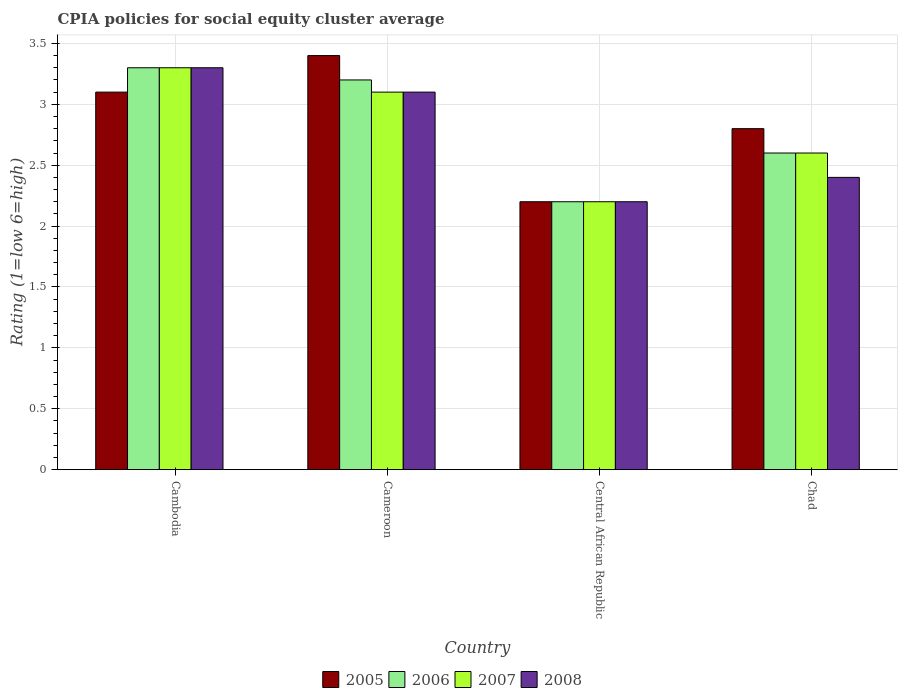How many different coloured bars are there?
Provide a succinct answer. 4. How many groups of bars are there?
Make the answer very short. 4. Are the number of bars on each tick of the X-axis equal?
Your response must be concise. Yes. How many bars are there on the 2nd tick from the right?
Your answer should be very brief. 4. What is the label of the 4th group of bars from the left?
Keep it short and to the point. Chad. What is the CPIA rating in 2008 in Cameroon?
Ensure brevity in your answer.  3.1. Across all countries, what is the maximum CPIA rating in 2005?
Your response must be concise. 3.4. In which country was the CPIA rating in 2006 maximum?
Ensure brevity in your answer.  Cambodia. In which country was the CPIA rating in 2005 minimum?
Keep it short and to the point. Central African Republic. What is the total CPIA rating in 2005 in the graph?
Your response must be concise. 11.5. What is the difference between the CPIA rating in 2008 in Cameroon and that in Chad?
Offer a very short reply. 0.7. What is the difference between the CPIA rating in 2005 in Cambodia and the CPIA rating in 2008 in Chad?
Offer a terse response. 0.7. What is the average CPIA rating in 2006 per country?
Make the answer very short. 2.82. What is the difference between the CPIA rating of/in 2005 and CPIA rating of/in 2007 in Cambodia?
Offer a terse response. -0.2. What is the ratio of the CPIA rating in 2005 in Cambodia to that in Cameroon?
Offer a terse response. 0.91. Is the CPIA rating in 2008 in Cameroon less than that in Chad?
Keep it short and to the point. No. Is the difference between the CPIA rating in 2005 in Cameroon and Chad greater than the difference between the CPIA rating in 2007 in Cameroon and Chad?
Offer a terse response. Yes. What is the difference between the highest and the second highest CPIA rating in 2005?
Your answer should be very brief. 0.3. What is the difference between the highest and the lowest CPIA rating in 2006?
Provide a short and direct response. 1.1. In how many countries, is the CPIA rating in 2006 greater than the average CPIA rating in 2006 taken over all countries?
Ensure brevity in your answer.  2. Is the sum of the CPIA rating in 2005 in Cambodia and Central African Republic greater than the maximum CPIA rating in 2006 across all countries?
Make the answer very short. Yes. What does the 1st bar from the right in Cambodia represents?
Provide a succinct answer. 2008. How many bars are there?
Make the answer very short. 16. How many countries are there in the graph?
Your response must be concise. 4. What is the difference between two consecutive major ticks on the Y-axis?
Keep it short and to the point. 0.5. Are the values on the major ticks of Y-axis written in scientific E-notation?
Keep it short and to the point. No. Where does the legend appear in the graph?
Keep it short and to the point. Bottom center. How many legend labels are there?
Ensure brevity in your answer.  4. How are the legend labels stacked?
Ensure brevity in your answer.  Horizontal. What is the title of the graph?
Make the answer very short. CPIA policies for social equity cluster average. Does "1982" appear as one of the legend labels in the graph?
Offer a terse response. No. What is the label or title of the Y-axis?
Your response must be concise. Rating (1=low 6=high). What is the Rating (1=low 6=high) in 2006 in Cambodia?
Keep it short and to the point. 3.3. What is the Rating (1=low 6=high) in 2007 in Cambodia?
Keep it short and to the point. 3.3. What is the Rating (1=low 6=high) of 2008 in Cambodia?
Offer a very short reply. 3.3. What is the Rating (1=low 6=high) in 2005 in Cameroon?
Your answer should be very brief. 3.4. What is the Rating (1=low 6=high) of 2006 in Cameroon?
Offer a very short reply. 3.2. What is the Rating (1=low 6=high) of 2007 in Cameroon?
Offer a very short reply. 3.1. What is the Rating (1=low 6=high) of 2006 in Central African Republic?
Provide a short and direct response. 2.2. What is the Rating (1=low 6=high) in 2007 in Central African Republic?
Ensure brevity in your answer.  2.2. What is the Rating (1=low 6=high) of 2008 in Central African Republic?
Provide a succinct answer. 2.2. What is the Rating (1=low 6=high) of 2005 in Chad?
Keep it short and to the point. 2.8. What is the Rating (1=low 6=high) in 2007 in Chad?
Provide a short and direct response. 2.6. What is the Rating (1=low 6=high) in 2008 in Chad?
Keep it short and to the point. 2.4. Across all countries, what is the maximum Rating (1=low 6=high) in 2005?
Your answer should be very brief. 3.4. Across all countries, what is the minimum Rating (1=low 6=high) in 2005?
Provide a short and direct response. 2.2. Across all countries, what is the minimum Rating (1=low 6=high) of 2006?
Provide a short and direct response. 2.2. Across all countries, what is the minimum Rating (1=low 6=high) of 2007?
Your response must be concise. 2.2. Across all countries, what is the minimum Rating (1=low 6=high) of 2008?
Provide a succinct answer. 2.2. What is the total Rating (1=low 6=high) of 2005 in the graph?
Ensure brevity in your answer.  11.5. What is the difference between the Rating (1=low 6=high) in 2005 in Cambodia and that in Cameroon?
Ensure brevity in your answer.  -0.3. What is the difference between the Rating (1=low 6=high) in 2008 in Cambodia and that in Cameroon?
Provide a short and direct response. 0.2. What is the difference between the Rating (1=low 6=high) in 2005 in Cambodia and that in Central African Republic?
Your answer should be compact. 0.9. What is the difference between the Rating (1=low 6=high) of 2006 in Cambodia and that in Central African Republic?
Ensure brevity in your answer.  1.1. What is the difference between the Rating (1=low 6=high) in 2008 in Cambodia and that in Central African Republic?
Your answer should be compact. 1.1. What is the difference between the Rating (1=low 6=high) of 2006 in Cambodia and that in Chad?
Make the answer very short. 0.7. What is the difference between the Rating (1=low 6=high) in 2007 in Cambodia and that in Chad?
Keep it short and to the point. 0.7. What is the difference between the Rating (1=low 6=high) in 2008 in Cambodia and that in Chad?
Provide a short and direct response. 0.9. What is the difference between the Rating (1=low 6=high) in 2005 in Cameroon and that in Central African Republic?
Offer a very short reply. 1.2. What is the difference between the Rating (1=low 6=high) of 2006 in Cameroon and that in Central African Republic?
Your answer should be very brief. 1. What is the difference between the Rating (1=low 6=high) of 2007 in Cameroon and that in Central African Republic?
Offer a terse response. 0.9. What is the difference between the Rating (1=low 6=high) in 2005 in Cameroon and that in Chad?
Make the answer very short. 0.6. What is the difference between the Rating (1=low 6=high) in 2006 in Cameroon and that in Chad?
Provide a short and direct response. 0.6. What is the difference between the Rating (1=low 6=high) of 2008 in Cameroon and that in Chad?
Offer a terse response. 0.7. What is the difference between the Rating (1=low 6=high) in 2005 in Central African Republic and that in Chad?
Offer a terse response. -0.6. What is the difference between the Rating (1=low 6=high) in 2006 in Central African Republic and that in Chad?
Provide a short and direct response. -0.4. What is the difference between the Rating (1=low 6=high) in 2007 in Central African Republic and that in Chad?
Ensure brevity in your answer.  -0.4. What is the difference between the Rating (1=low 6=high) of 2005 in Cambodia and the Rating (1=low 6=high) of 2007 in Cameroon?
Keep it short and to the point. 0. What is the difference between the Rating (1=low 6=high) in 2006 in Cambodia and the Rating (1=low 6=high) in 2007 in Cameroon?
Offer a very short reply. 0.2. What is the difference between the Rating (1=low 6=high) in 2006 in Cambodia and the Rating (1=low 6=high) in 2008 in Cameroon?
Provide a short and direct response. 0.2. What is the difference between the Rating (1=low 6=high) in 2007 in Cambodia and the Rating (1=low 6=high) in 2008 in Cameroon?
Your response must be concise. 0.2. What is the difference between the Rating (1=low 6=high) of 2005 in Cambodia and the Rating (1=low 6=high) of 2006 in Central African Republic?
Provide a succinct answer. 0.9. What is the difference between the Rating (1=low 6=high) of 2005 in Cambodia and the Rating (1=low 6=high) of 2008 in Central African Republic?
Give a very brief answer. 0.9. What is the difference between the Rating (1=low 6=high) of 2005 in Cambodia and the Rating (1=low 6=high) of 2006 in Chad?
Your answer should be very brief. 0.5. What is the difference between the Rating (1=low 6=high) in 2006 in Cambodia and the Rating (1=low 6=high) in 2008 in Chad?
Your response must be concise. 0.9. What is the difference between the Rating (1=low 6=high) in 2005 in Cameroon and the Rating (1=low 6=high) in 2007 in Central African Republic?
Keep it short and to the point. 1.2. What is the difference between the Rating (1=low 6=high) of 2007 in Cameroon and the Rating (1=low 6=high) of 2008 in Chad?
Give a very brief answer. 0.7. What is the difference between the Rating (1=low 6=high) of 2005 in Central African Republic and the Rating (1=low 6=high) of 2006 in Chad?
Make the answer very short. -0.4. What is the difference between the Rating (1=low 6=high) of 2005 in Central African Republic and the Rating (1=low 6=high) of 2007 in Chad?
Your answer should be compact. -0.4. What is the difference between the Rating (1=low 6=high) in 2005 in Central African Republic and the Rating (1=low 6=high) in 2008 in Chad?
Provide a short and direct response. -0.2. What is the difference between the Rating (1=low 6=high) in 2007 in Central African Republic and the Rating (1=low 6=high) in 2008 in Chad?
Your answer should be compact. -0.2. What is the average Rating (1=low 6=high) in 2005 per country?
Ensure brevity in your answer.  2.88. What is the average Rating (1=low 6=high) of 2006 per country?
Keep it short and to the point. 2.83. What is the average Rating (1=low 6=high) of 2008 per country?
Offer a terse response. 2.75. What is the difference between the Rating (1=low 6=high) of 2005 and Rating (1=low 6=high) of 2006 in Cambodia?
Give a very brief answer. -0.2. What is the difference between the Rating (1=low 6=high) in 2005 and Rating (1=low 6=high) in 2008 in Cambodia?
Give a very brief answer. -0.2. What is the difference between the Rating (1=low 6=high) of 2006 and Rating (1=low 6=high) of 2007 in Cambodia?
Offer a terse response. 0. What is the difference between the Rating (1=low 6=high) of 2007 and Rating (1=low 6=high) of 2008 in Cambodia?
Provide a succinct answer. 0. What is the difference between the Rating (1=low 6=high) of 2005 and Rating (1=low 6=high) of 2007 in Cameroon?
Ensure brevity in your answer.  0.3. What is the difference between the Rating (1=low 6=high) of 2005 and Rating (1=low 6=high) of 2008 in Cameroon?
Your answer should be compact. 0.3. What is the difference between the Rating (1=low 6=high) of 2007 and Rating (1=low 6=high) of 2008 in Cameroon?
Make the answer very short. 0. What is the difference between the Rating (1=low 6=high) of 2005 and Rating (1=low 6=high) of 2006 in Central African Republic?
Offer a terse response. 0. What is the difference between the Rating (1=low 6=high) of 2005 and Rating (1=low 6=high) of 2008 in Central African Republic?
Give a very brief answer. 0. What is the difference between the Rating (1=low 6=high) of 2007 and Rating (1=low 6=high) of 2008 in Chad?
Your answer should be compact. 0.2. What is the ratio of the Rating (1=low 6=high) in 2005 in Cambodia to that in Cameroon?
Offer a very short reply. 0.91. What is the ratio of the Rating (1=low 6=high) in 2006 in Cambodia to that in Cameroon?
Your response must be concise. 1.03. What is the ratio of the Rating (1=low 6=high) in 2007 in Cambodia to that in Cameroon?
Provide a short and direct response. 1.06. What is the ratio of the Rating (1=low 6=high) in 2008 in Cambodia to that in Cameroon?
Provide a short and direct response. 1.06. What is the ratio of the Rating (1=low 6=high) of 2005 in Cambodia to that in Central African Republic?
Provide a short and direct response. 1.41. What is the ratio of the Rating (1=low 6=high) in 2006 in Cambodia to that in Central African Republic?
Provide a short and direct response. 1.5. What is the ratio of the Rating (1=low 6=high) of 2005 in Cambodia to that in Chad?
Offer a very short reply. 1.11. What is the ratio of the Rating (1=low 6=high) in 2006 in Cambodia to that in Chad?
Provide a succinct answer. 1.27. What is the ratio of the Rating (1=low 6=high) of 2007 in Cambodia to that in Chad?
Your answer should be compact. 1.27. What is the ratio of the Rating (1=low 6=high) of 2008 in Cambodia to that in Chad?
Your response must be concise. 1.38. What is the ratio of the Rating (1=low 6=high) in 2005 in Cameroon to that in Central African Republic?
Provide a succinct answer. 1.55. What is the ratio of the Rating (1=low 6=high) of 2006 in Cameroon to that in Central African Republic?
Your response must be concise. 1.45. What is the ratio of the Rating (1=low 6=high) in 2007 in Cameroon to that in Central African Republic?
Make the answer very short. 1.41. What is the ratio of the Rating (1=low 6=high) of 2008 in Cameroon to that in Central African Republic?
Provide a short and direct response. 1.41. What is the ratio of the Rating (1=low 6=high) in 2005 in Cameroon to that in Chad?
Offer a very short reply. 1.21. What is the ratio of the Rating (1=low 6=high) of 2006 in Cameroon to that in Chad?
Ensure brevity in your answer.  1.23. What is the ratio of the Rating (1=low 6=high) in 2007 in Cameroon to that in Chad?
Offer a very short reply. 1.19. What is the ratio of the Rating (1=low 6=high) in 2008 in Cameroon to that in Chad?
Your answer should be very brief. 1.29. What is the ratio of the Rating (1=low 6=high) of 2005 in Central African Republic to that in Chad?
Offer a very short reply. 0.79. What is the ratio of the Rating (1=low 6=high) of 2006 in Central African Republic to that in Chad?
Give a very brief answer. 0.85. What is the ratio of the Rating (1=low 6=high) of 2007 in Central African Republic to that in Chad?
Ensure brevity in your answer.  0.85. What is the difference between the highest and the second highest Rating (1=low 6=high) in 2006?
Keep it short and to the point. 0.1. What is the difference between the highest and the lowest Rating (1=low 6=high) of 2005?
Your answer should be compact. 1.2. What is the difference between the highest and the lowest Rating (1=low 6=high) of 2006?
Your answer should be compact. 1.1. 